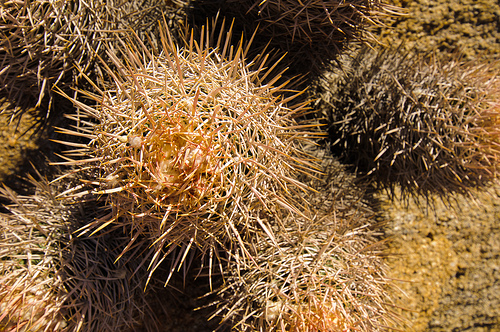<image>
Can you confirm if the cactus is above the soil? Yes. The cactus is positioned above the soil in the vertical space, higher up in the scene. 